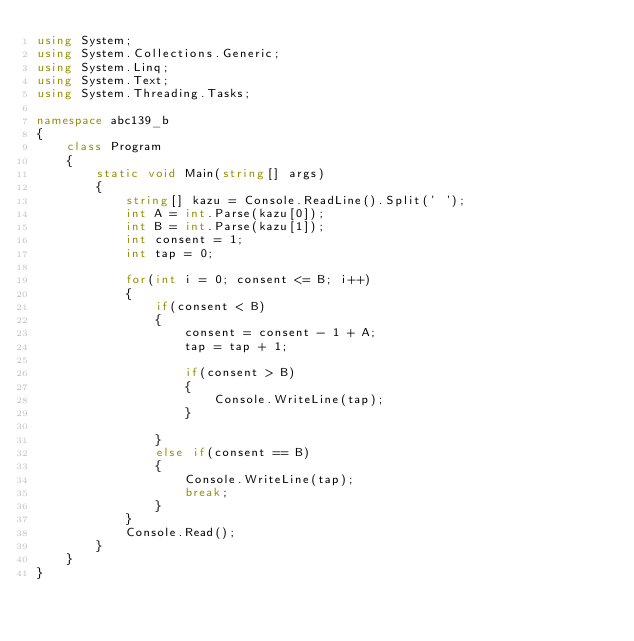<code> <loc_0><loc_0><loc_500><loc_500><_C#_>using System;
using System.Collections.Generic;
using System.Linq;
using System.Text;
using System.Threading.Tasks;

namespace abc139_b
{
    class Program
    {
        static void Main(string[] args)
        {
            string[] kazu = Console.ReadLine().Split(' ');
            int A = int.Parse(kazu[0]);
            int B = int.Parse(kazu[1]);
            int consent = 1;
            int tap = 0;

            for(int i = 0; consent <= B; i++)
            {
                if(consent < B)
                {
                    consent = consent - 1 + A;
                    tap = tap + 1;

                    if(consent > B)
                    {
                        Console.WriteLine(tap);
                    }
                    
                }
                else if(consent == B)
                {
                    Console.WriteLine(tap);
                    break;
                }
            }
            Console.Read();
        }
    }
}
</code> 